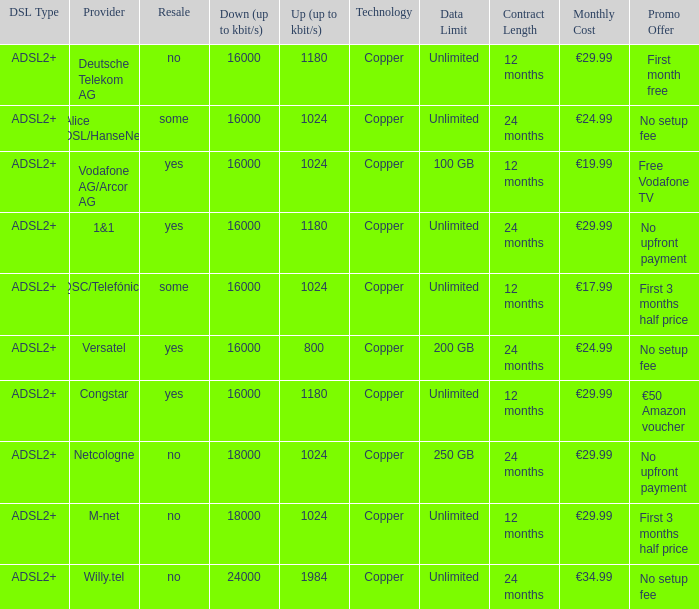What are all the dsl type offered by the M-Net telecom company? ADSL2+. 